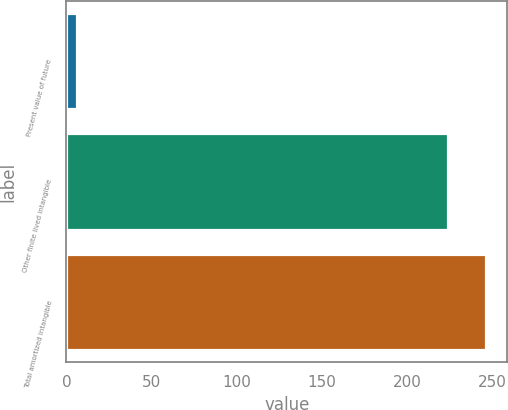<chart> <loc_0><loc_0><loc_500><loc_500><bar_chart><fcel>Present value of future<fcel>Other finite lived intangible<fcel>Total amortized intangible<nl><fcel>6.1<fcel>224.1<fcel>246.51<nl></chart> 